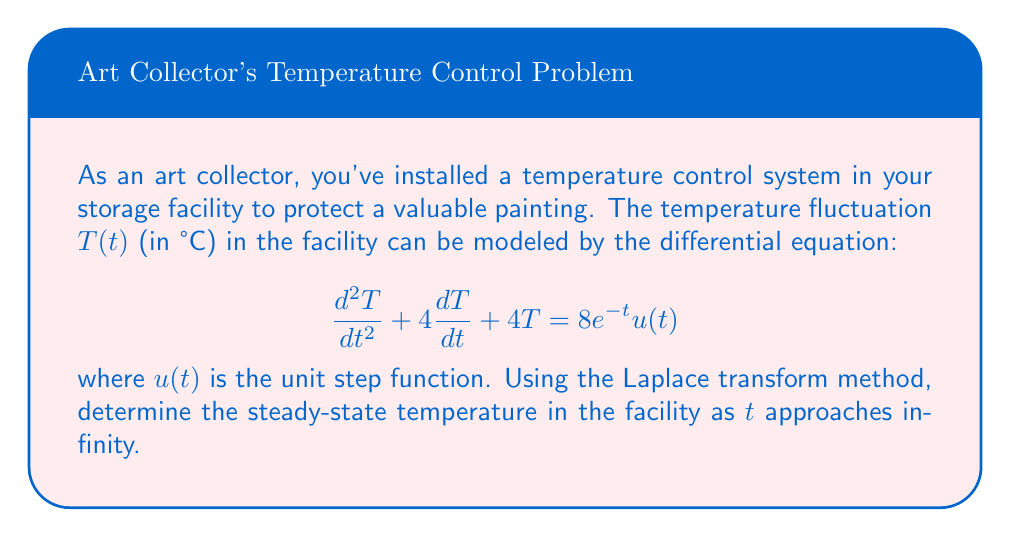Provide a solution to this math problem. Let's solve this problem step-by-step using the Laplace transform method:

1) Take the Laplace transform of both sides of the equation:
   $$\mathcal{L}\{T''(t) + 4T'(t) + 4T(t)\} = \mathcal{L}\{8e^{-t}u(t)\}$$

2) Using Laplace transform properties:
   $$(s^2T(s) - sT(0) - T'(0)) + 4(sT(s) - T(0)) + 4T(s) = \frac{8}{s+1}$$
   
   Assume initial conditions $T(0) = 0$ and $T'(0) = 0$:
   
   $$s^2T(s) + 4sT(s) + 4T(s) = \frac{8}{s+1}$$

3) Factor out $T(s)$:
   $$T(s)(s^2 + 4s + 4) = \frac{8}{s+1}$$

4) Solve for $T(s)$:
   $$T(s) = \frac{8}{(s+1)(s^2 + 4s + 4)} = \frac{8}{(s+1)(s+2)^2}$$

5) To find the steady-state temperature, we use the Final Value Theorem:
   $$\lim_{t \to \infty} T(t) = \lim_{s \to 0} sT(s)$$

6) Apply the limit:
   $$\lim_{s \to 0} s \cdot \frac{8}{(s+1)(s+2)^2} = \lim_{s \to 0} \frac{8s}{(s+1)(s+2)^2} = \frac{8 \cdot 0}{(0+1)(0+2)^2} = 0$$

Therefore, the steady-state temperature in the facility as $t$ approaches infinity is 0°C.
Answer: 0°C 